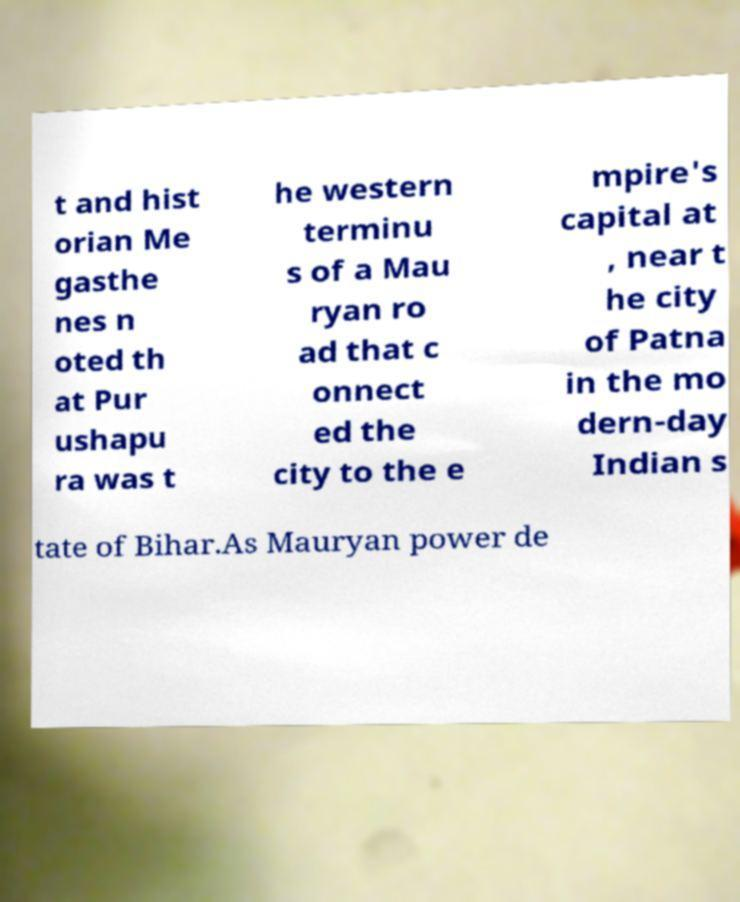I need the written content from this picture converted into text. Can you do that? t and hist orian Me gasthe nes n oted th at Pur ushapu ra was t he western terminu s of a Mau ryan ro ad that c onnect ed the city to the e mpire's capital at , near t he city of Patna in the mo dern-day Indian s tate of Bihar.As Mauryan power de 